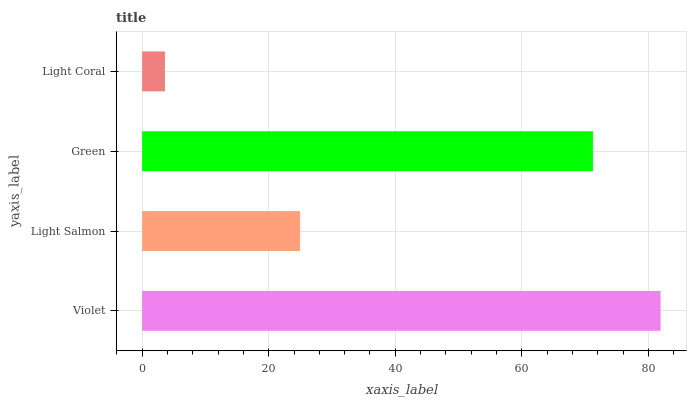Is Light Coral the minimum?
Answer yes or no. Yes. Is Violet the maximum?
Answer yes or no. Yes. Is Light Salmon the minimum?
Answer yes or no. No. Is Light Salmon the maximum?
Answer yes or no. No. Is Violet greater than Light Salmon?
Answer yes or no. Yes. Is Light Salmon less than Violet?
Answer yes or no. Yes. Is Light Salmon greater than Violet?
Answer yes or no. No. Is Violet less than Light Salmon?
Answer yes or no. No. Is Green the high median?
Answer yes or no. Yes. Is Light Salmon the low median?
Answer yes or no. Yes. Is Violet the high median?
Answer yes or no. No. Is Light Coral the low median?
Answer yes or no. No. 